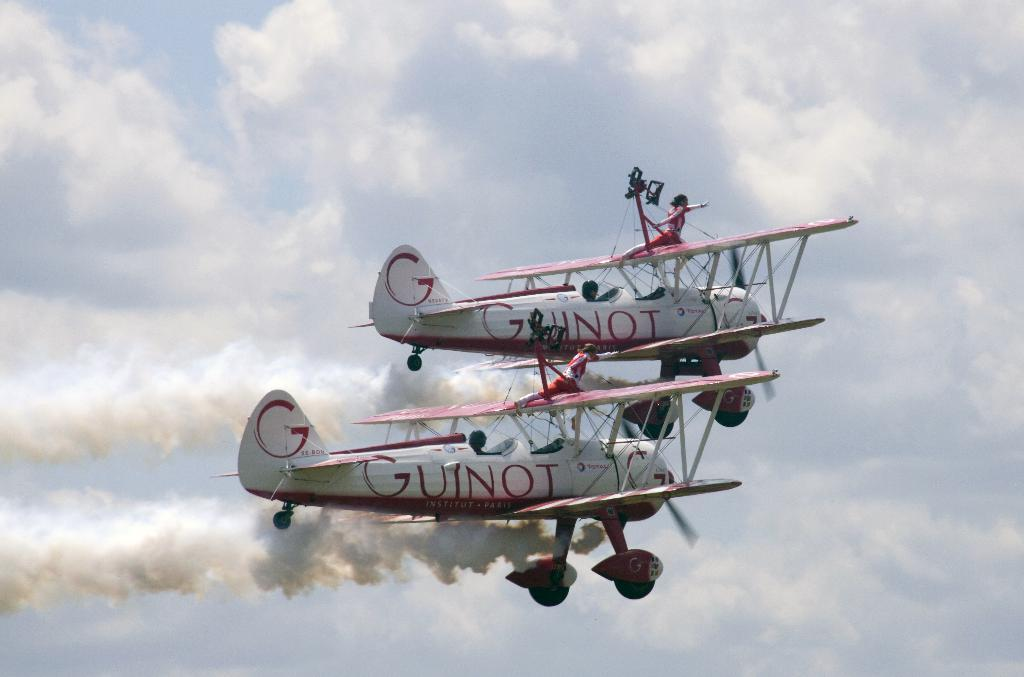<image>
Give a short and clear explanation of the subsequent image. a plane with Guinot written on the side of it 